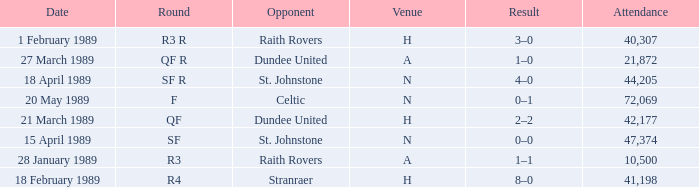What is the date when the rotation is sf? 15 April 1989. 